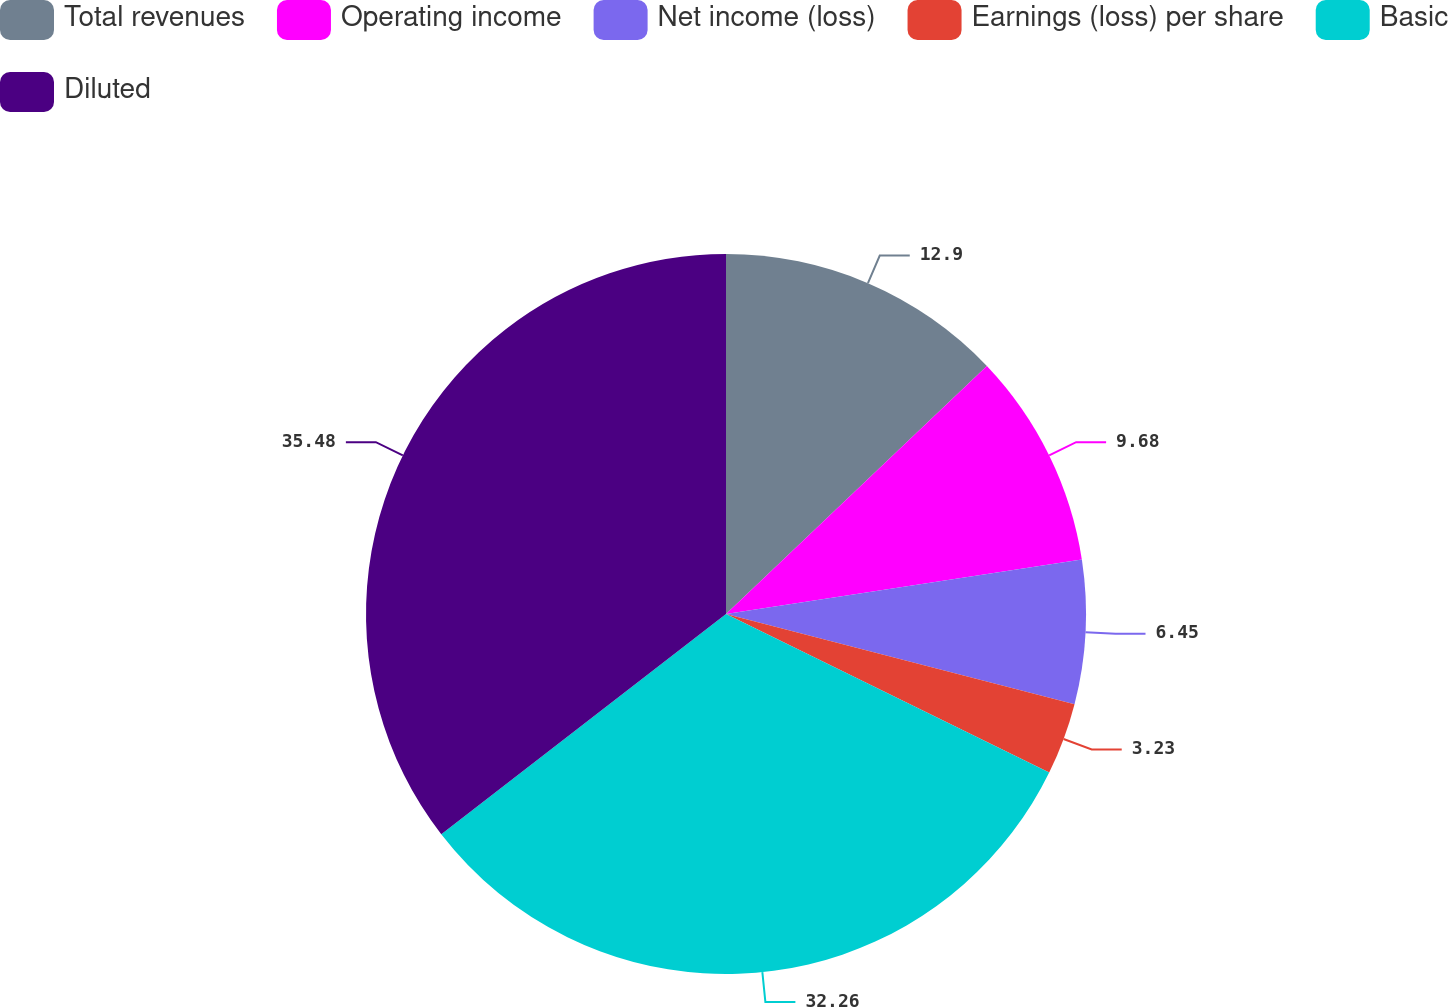<chart> <loc_0><loc_0><loc_500><loc_500><pie_chart><fcel>Total revenues<fcel>Operating income<fcel>Net income (loss)<fcel>Earnings (loss) per share<fcel>Basic<fcel>Diluted<nl><fcel>12.9%<fcel>9.68%<fcel>6.45%<fcel>3.23%<fcel>32.26%<fcel>35.48%<nl></chart> 